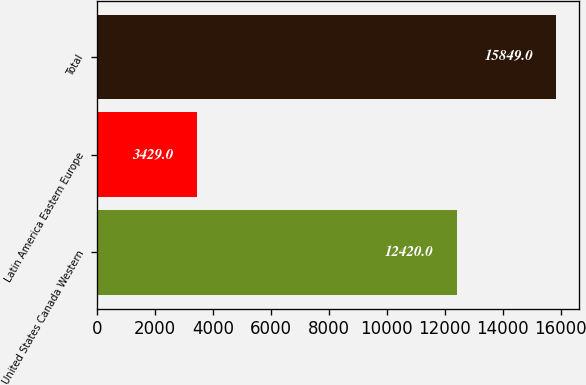Convert chart to OTSL. <chart><loc_0><loc_0><loc_500><loc_500><bar_chart><fcel>United States Canada Western<fcel>Latin America Eastern Europe<fcel>Total<nl><fcel>12420<fcel>3429<fcel>15849<nl></chart> 